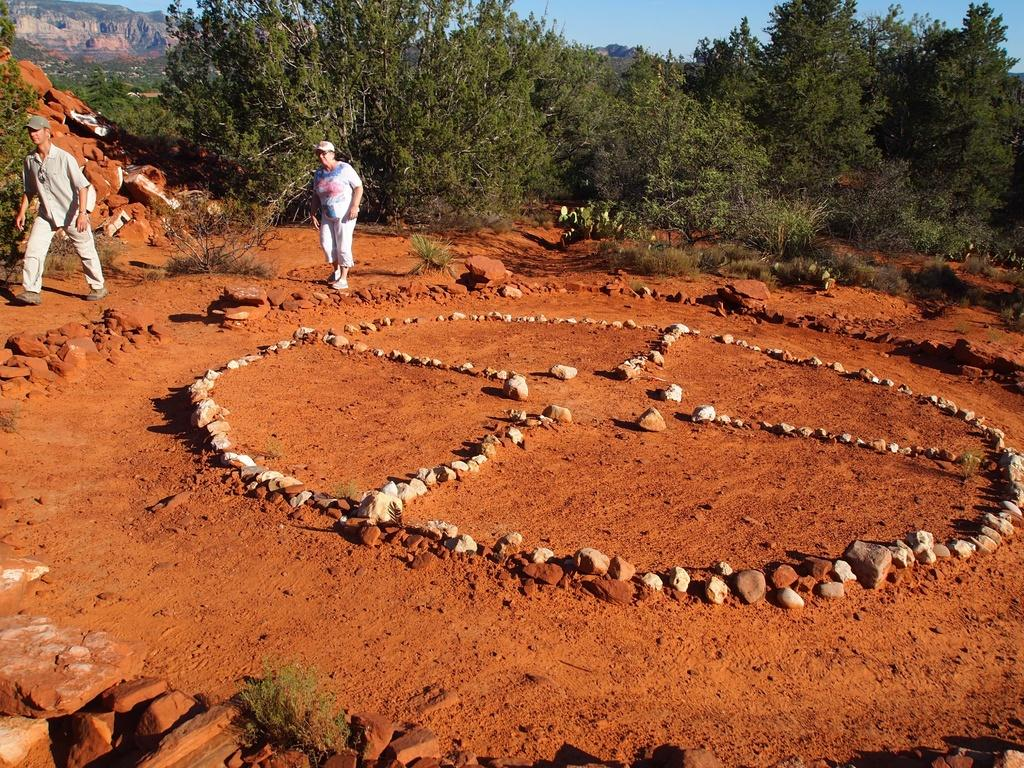How many people are in the image? There are two people in the image. What are the people wearing? The people are wearing dresses and caps. What type of objects can be seen on the ground in the image? There are stones in the image. What type of vegetation is present in the image? There are plants and many trees in the image. What can be seen in the distance in the image? There are mountains visible in the background of the image. What is visible above the mountains in the image? The sky is visible in the background of the image. What type of skin condition can be seen on the people's faces in the image? There is no indication of any skin condition on the people's faces in the image. What kind of crook is present in the image? There is no crook present in the image. 